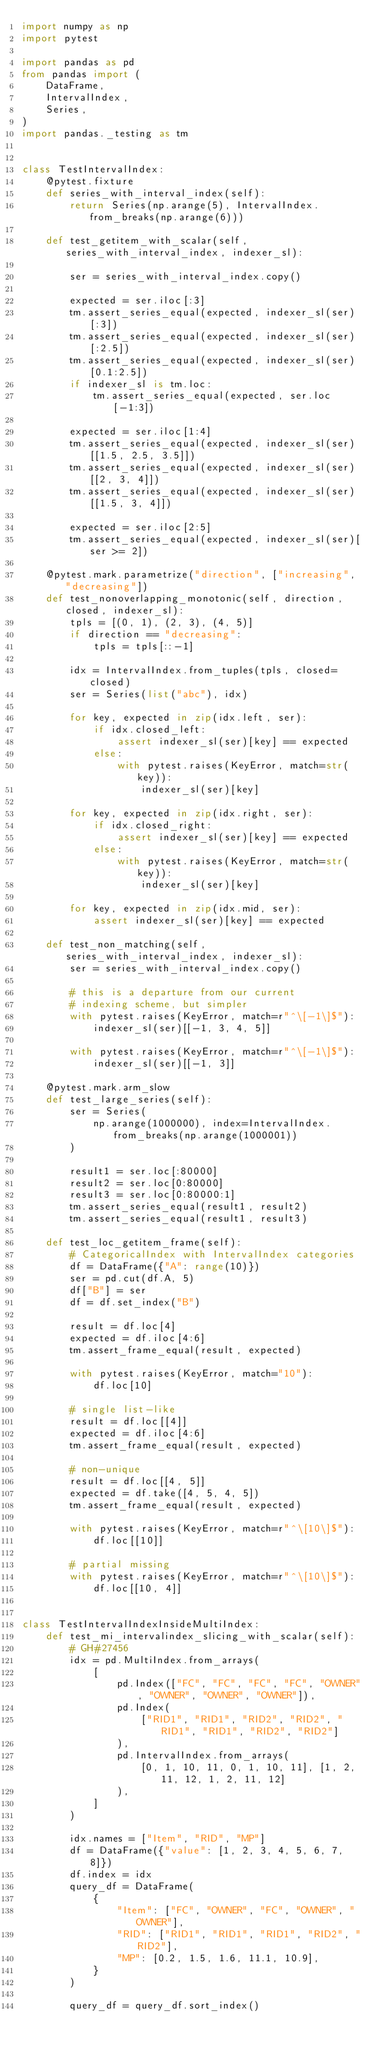<code> <loc_0><loc_0><loc_500><loc_500><_Python_>import numpy as np
import pytest

import pandas as pd
from pandas import (
    DataFrame,
    IntervalIndex,
    Series,
)
import pandas._testing as tm


class TestIntervalIndex:
    @pytest.fixture
    def series_with_interval_index(self):
        return Series(np.arange(5), IntervalIndex.from_breaks(np.arange(6)))

    def test_getitem_with_scalar(self, series_with_interval_index, indexer_sl):

        ser = series_with_interval_index.copy()

        expected = ser.iloc[:3]
        tm.assert_series_equal(expected, indexer_sl(ser)[:3])
        tm.assert_series_equal(expected, indexer_sl(ser)[:2.5])
        tm.assert_series_equal(expected, indexer_sl(ser)[0.1:2.5])
        if indexer_sl is tm.loc:
            tm.assert_series_equal(expected, ser.loc[-1:3])

        expected = ser.iloc[1:4]
        tm.assert_series_equal(expected, indexer_sl(ser)[[1.5, 2.5, 3.5]])
        tm.assert_series_equal(expected, indexer_sl(ser)[[2, 3, 4]])
        tm.assert_series_equal(expected, indexer_sl(ser)[[1.5, 3, 4]])

        expected = ser.iloc[2:5]
        tm.assert_series_equal(expected, indexer_sl(ser)[ser >= 2])

    @pytest.mark.parametrize("direction", ["increasing", "decreasing"])
    def test_nonoverlapping_monotonic(self, direction, closed, indexer_sl):
        tpls = [(0, 1), (2, 3), (4, 5)]
        if direction == "decreasing":
            tpls = tpls[::-1]

        idx = IntervalIndex.from_tuples(tpls, closed=closed)
        ser = Series(list("abc"), idx)

        for key, expected in zip(idx.left, ser):
            if idx.closed_left:
                assert indexer_sl(ser)[key] == expected
            else:
                with pytest.raises(KeyError, match=str(key)):
                    indexer_sl(ser)[key]

        for key, expected in zip(idx.right, ser):
            if idx.closed_right:
                assert indexer_sl(ser)[key] == expected
            else:
                with pytest.raises(KeyError, match=str(key)):
                    indexer_sl(ser)[key]

        for key, expected in zip(idx.mid, ser):
            assert indexer_sl(ser)[key] == expected

    def test_non_matching(self, series_with_interval_index, indexer_sl):
        ser = series_with_interval_index.copy()

        # this is a departure from our current
        # indexing scheme, but simpler
        with pytest.raises(KeyError, match=r"^\[-1\]$"):
            indexer_sl(ser)[[-1, 3, 4, 5]]

        with pytest.raises(KeyError, match=r"^\[-1\]$"):
            indexer_sl(ser)[[-1, 3]]

    @pytest.mark.arm_slow
    def test_large_series(self):
        ser = Series(
            np.arange(1000000), index=IntervalIndex.from_breaks(np.arange(1000001))
        )

        result1 = ser.loc[:80000]
        result2 = ser.loc[0:80000]
        result3 = ser.loc[0:80000:1]
        tm.assert_series_equal(result1, result2)
        tm.assert_series_equal(result1, result3)

    def test_loc_getitem_frame(self):
        # CategoricalIndex with IntervalIndex categories
        df = DataFrame({"A": range(10)})
        ser = pd.cut(df.A, 5)
        df["B"] = ser
        df = df.set_index("B")

        result = df.loc[4]
        expected = df.iloc[4:6]
        tm.assert_frame_equal(result, expected)

        with pytest.raises(KeyError, match="10"):
            df.loc[10]

        # single list-like
        result = df.loc[[4]]
        expected = df.iloc[4:6]
        tm.assert_frame_equal(result, expected)

        # non-unique
        result = df.loc[[4, 5]]
        expected = df.take([4, 5, 4, 5])
        tm.assert_frame_equal(result, expected)

        with pytest.raises(KeyError, match=r"^\[10\]$"):
            df.loc[[10]]

        # partial missing
        with pytest.raises(KeyError, match=r"^\[10\]$"):
            df.loc[[10, 4]]


class TestIntervalIndexInsideMultiIndex:
    def test_mi_intervalindex_slicing_with_scalar(self):
        # GH#27456
        idx = pd.MultiIndex.from_arrays(
            [
                pd.Index(["FC", "FC", "FC", "FC", "OWNER", "OWNER", "OWNER", "OWNER"]),
                pd.Index(
                    ["RID1", "RID1", "RID2", "RID2", "RID1", "RID1", "RID2", "RID2"]
                ),
                pd.IntervalIndex.from_arrays(
                    [0, 1, 10, 11, 0, 1, 10, 11], [1, 2, 11, 12, 1, 2, 11, 12]
                ),
            ]
        )

        idx.names = ["Item", "RID", "MP"]
        df = DataFrame({"value": [1, 2, 3, 4, 5, 6, 7, 8]})
        df.index = idx
        query_df = DataFrame(
            {
                "Item": ["FC", "OWNER", "FC", "OWNER", "OWNER"],
                "RID": ["RID1", "RID1", "RID1", "RID2", "RID2"],
                "MP": [0.2, 1.5, 1.6, 11.1, 10.9],
            }
        )

        query_df = query_df.sort_index()
</code> 